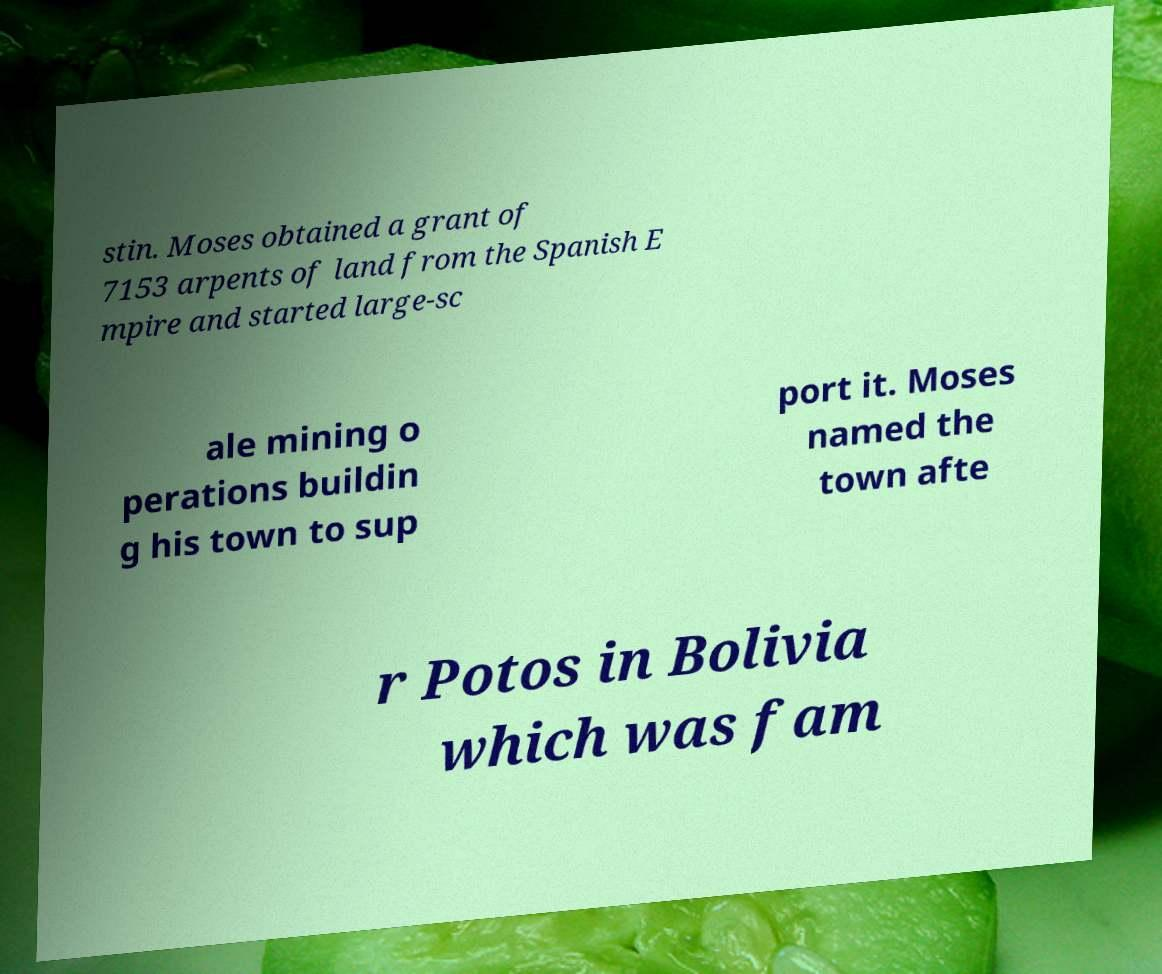Please read and relay the text visible in this image. What does it say? stin. Moses obtained a grant of 7153 arpents of land from the Spanish E mpire and started large-sc ale mining o perations buildin g his town to sup port it. Moses named the town afte r Potos in Bolivia which was fam 